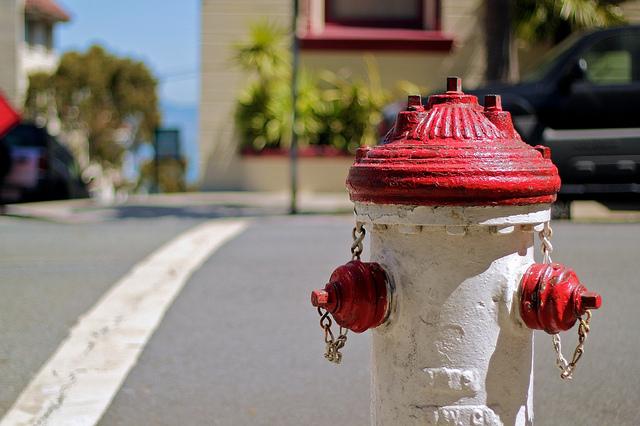What is the primary hydrant color?
Write a very short answer. White. What would a dog be attracted to here?
Short answer required. Fire hydrant. What color is the top of the hydrant?
Concise answer only. Red. 